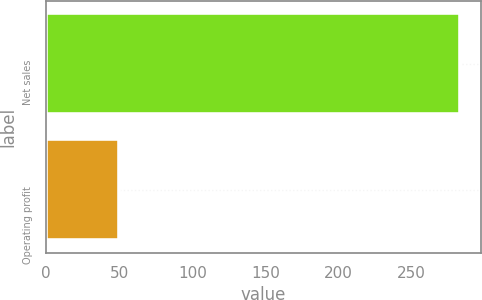<chart> <loc_0><loc_0><loc_500><loc_500><bar_chart><fcel>Net sales<fcel>Operating profit<nl><fcel>283<fcel>50<nl></chart> 